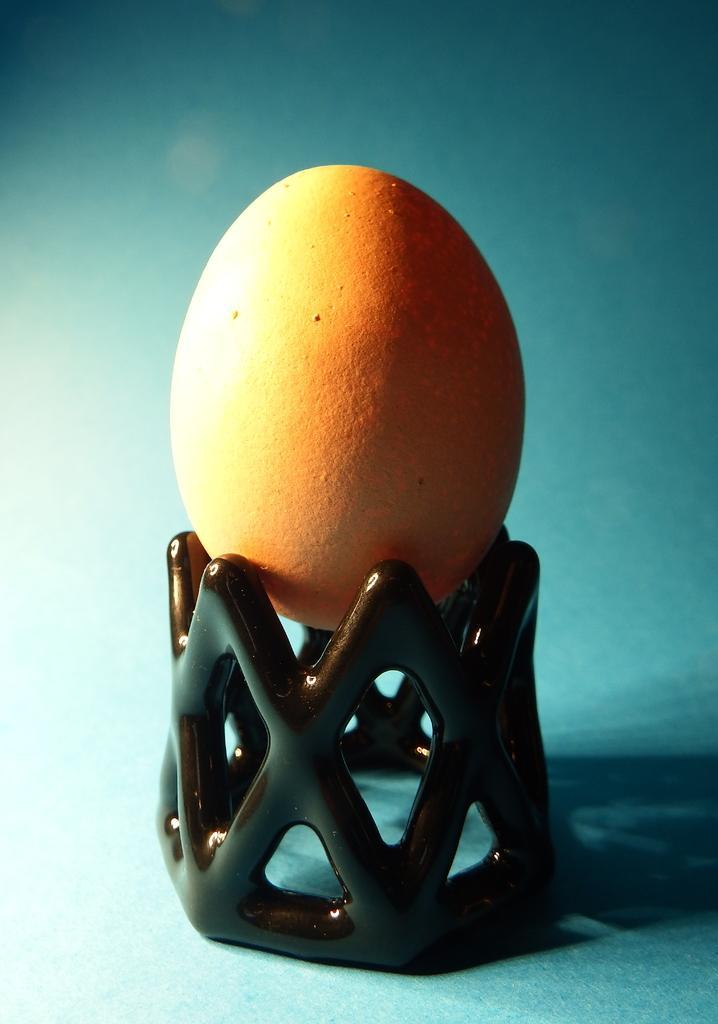Can you describe this image briefly? In this image, we can see an egg on object. 